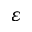Convert formula to latex. <formula><loc_0><loc_0><loc_500><loc_500>\varepsilon</formula> 